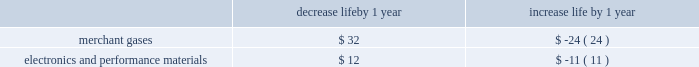Economic useful life is the duration of time an asset is expected to be productively employed by us , which may be less than its physical life .
Assumptions on the following factors , among others , affect the determination of estimated economic useful life : wear and tear , obsolescence , technical standards , contract life , market demand , competitive position , raw material availability , and geographic location .
The estimated economic useful life of an asset is monitored to determine its appropriateness , especially in light of changed business circumstances .
For example , changes in technology , changes in the estimated future demand for products , or excessive wear and tear may result in a shorter estimated useful life than originally anticipated .
In these cases , we would depreciate the remaining net book value over the new estimated remaining life , thereby increasing depreciation expense per year on a prospective basis .
Likewise , if the estimated useful life is increased , the adjustment to the useful life decreases depreciation expense per year on a prospective basis .
We have numerous long-term customer supply contracts , particularly in the gases on-site business within the tonnage gases segment .
These contracts principally have initial contract terms of 15 to 20 years .
There are also long-term customer supply contracts associated with the tonnage gases business within the electronics and performance materials segment .
These contracts principally have initial terms of 10 to 15 years .
Additionally , we have several customer supply contracts within the equipment and energy segment with contract terms that are primarily five to 10 years .
The depreciable lives of assets within this segment can be extended to 20 years for certain redeployable assets .
Depreciable lives of the production assets related to long-term contracts are matched to the contract lives .
Extensions to the contract term of supply frequently occur prior to the expiration of the initial term .
As contract terms are extended , the depreciable life of the remaining net book value of the production assets is adjusted to match the new contract term , as long as it does not exceed the physical life of the asset .
The depreciable lives of production facilities within the merchant gases segment are principally 15 years .
Customer contracts associated with products produced at these types of facilities typically have a much shorter term .
The depreciable lives of production facilities within the electronics and performance materials segment , where there is not an associated long-term supply agreement , range from 10 to 15 years .
These depreciable lives have been determined based on historical experience combined with judgment on future assumptions such as technological advances , potential obsolescence , competitors 2019 actions , etc .
Management monitors its assumptions and may potentially need to adjust depreciable life as circumstances change .
A change in the depreciable life by one year for production facilities within the merchant gases and electronics and performance materials segments for which there is not an associated long-term customer supply agreement would impact annual depreciation expense as summarized below : decrease life by 1 year increase life by 1 year .
Impairment of assets plant and equipment plant and equipment held for use is grouped for impairment testing at the lowest level for which there is identifiable cash flows .
Impairment testing of the asset group occurs whenever events or changes in circumstances indicate that the carrying amount of the assets may not be recoverable .
Such circumstances would include a significant decrease in the market value of a long-lived asset grouping , a significant adverse change in the manner in which the asset grouping is being used or in its physical condition , a history of operating or cash flow losses associated with the use of the asset grouping , or changes in the expected useful life of the long-lived assets .
If such circumstances are determined to exist , an estimate of undiscounted future cash flows produced by that asset group is compared to the carrying value to determine whether impairment exists .
If an asset group is determined to be impaired , the loss is measured based on the difference between the asset group 2019s fair value and its carrying value .
An estimate of the asset group 2019s fair value is based on the discounted value of its estimated cash flows .
Assets to be disposed of by sale are reported at the lower of carrying amount or fair value less cost to sell .
The assumptions underlying cash flow projections represent management 2019s best estimates at the time of the impairment review .
Factors that management must estimate include industry and market conditions , sales volume and prices , costs to produce , inflation , etc .
Changes in key assumptions or actual conditions that differ from estimates could result in an impairment charge .
We use reasonable and supportable assumptions when performing .
Considering the contract terms of 15 years , what will be the total expense with the depreciation of the merchant gases segment?\\n? 
Rationale: it is the number of years of the contract multiplied by the increased life by year .
Computations: (24 * 15)
Answer: 360.0. 